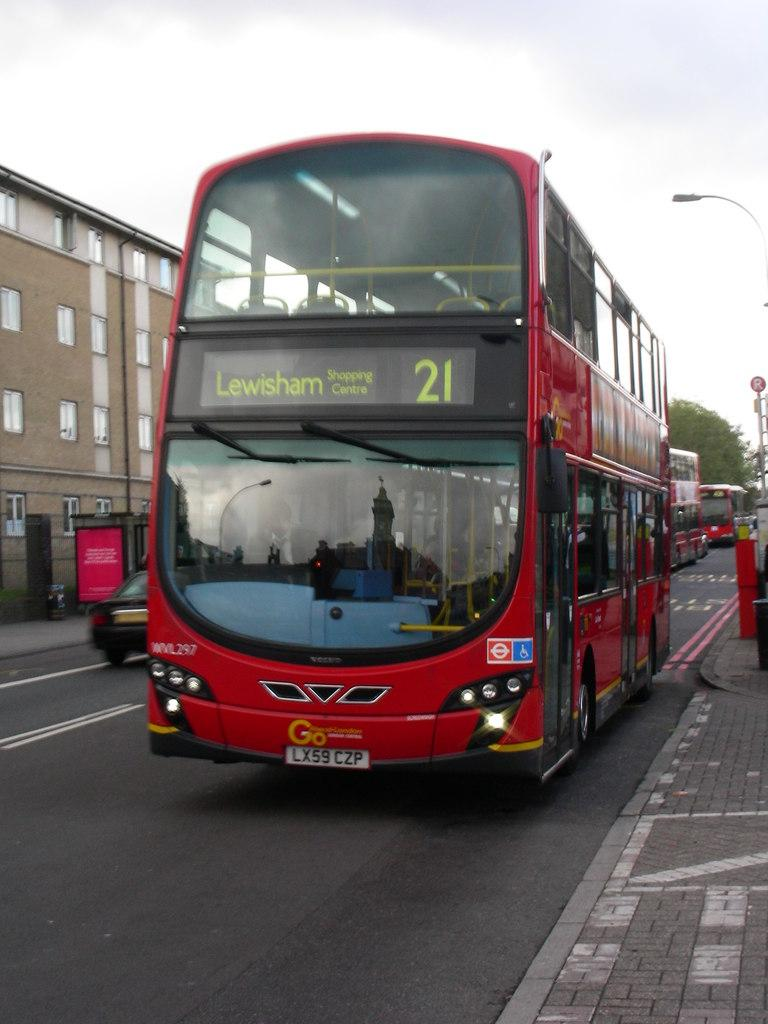<image>
Share a concise interpretation of the image provided. Bus number 21 is heading the the Lewisham shopping centre. 